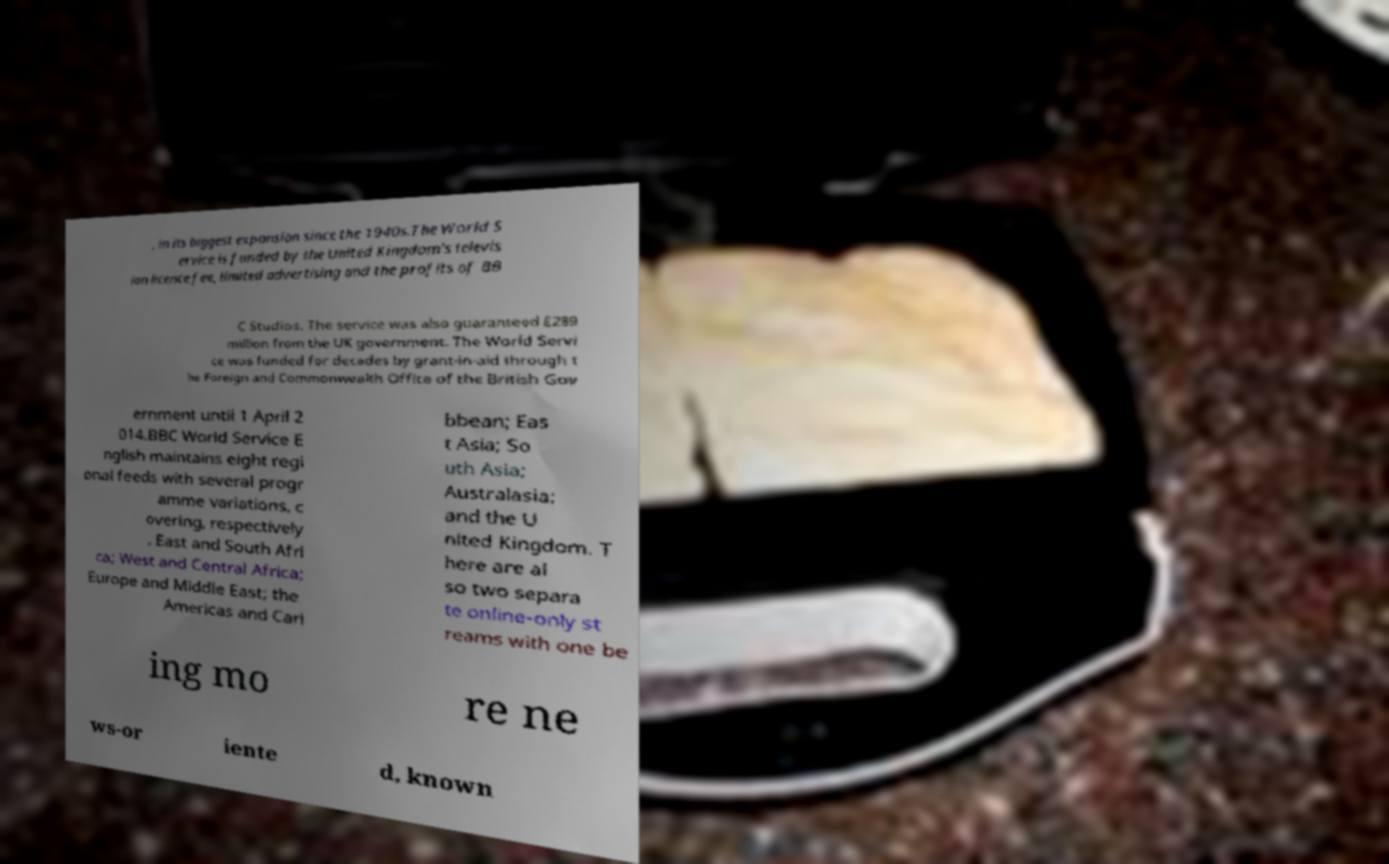Could you assist in decoding the text presented in this image and type it out clearly? , in its biggest expansion since the 1940s.The World S ervice is funded by the United Kingdom's televis ion licence fee, limited advertising and the profits of BB C Studios. The service was also guaranteed £289 million from the UK government. The World Servi ce was funded for decades by grant-in-aid through t he Foreign and Commonwealth Office of the British Gov ernment until 1 April 2 014.BBC World Service E nglish maintains eight regi onal feeds with several progr amme variations, c overing, respectively , East and South Afri ca; West and Central Africa; Europe and Middle East; the Americas and Cari bbean; Eas t Asia; So uth Asia; Australasia; and the U nited Kingdom. T here are al so two separa te online-only st reams with one be ing mo re ne ws-or iente d, known 